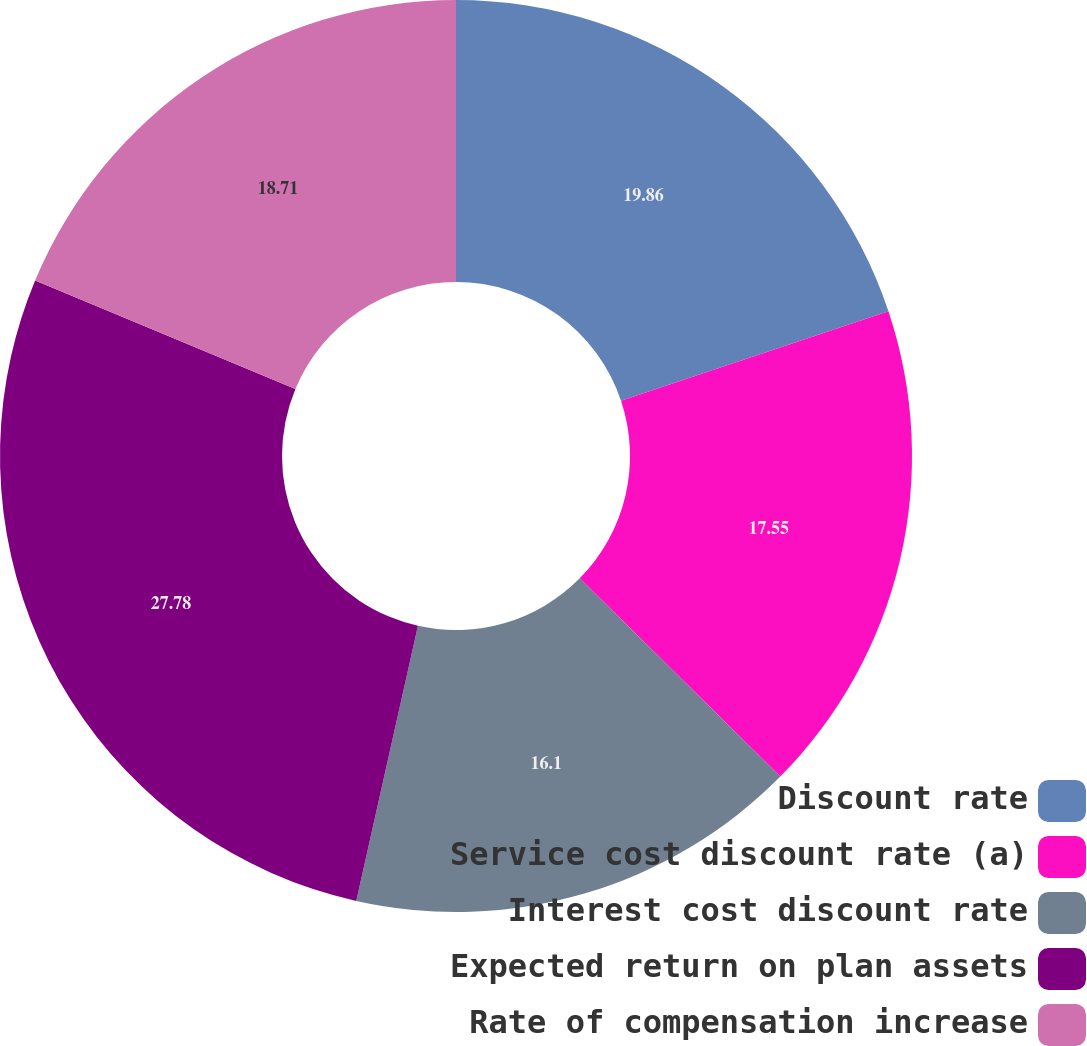Convert chart. <chart><loc_0><loc_0><loc_500><loc_500><pie_chart><fcel>Discount rate<fcel>Service cost discount rate (a)<fcel>Interest cost discount rate<fcel>Expected return on plan assets<fcel>Rate of compensation increase<nl><fcel>19.86%<fcel>17.55%<fcel>16.1%<fcel>27.78%<fcel>18.71%<nl></chart> 